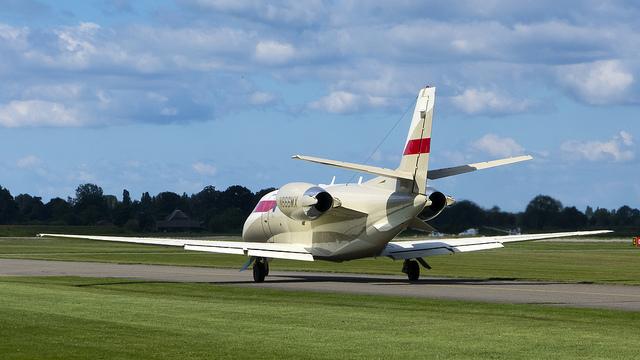What is hanging behind the wings?
Be succinct. Flaps. Are there clouds in the sky?
Write a very short answer. Yes. Is the sky clear?
Write a very short answer. No. 